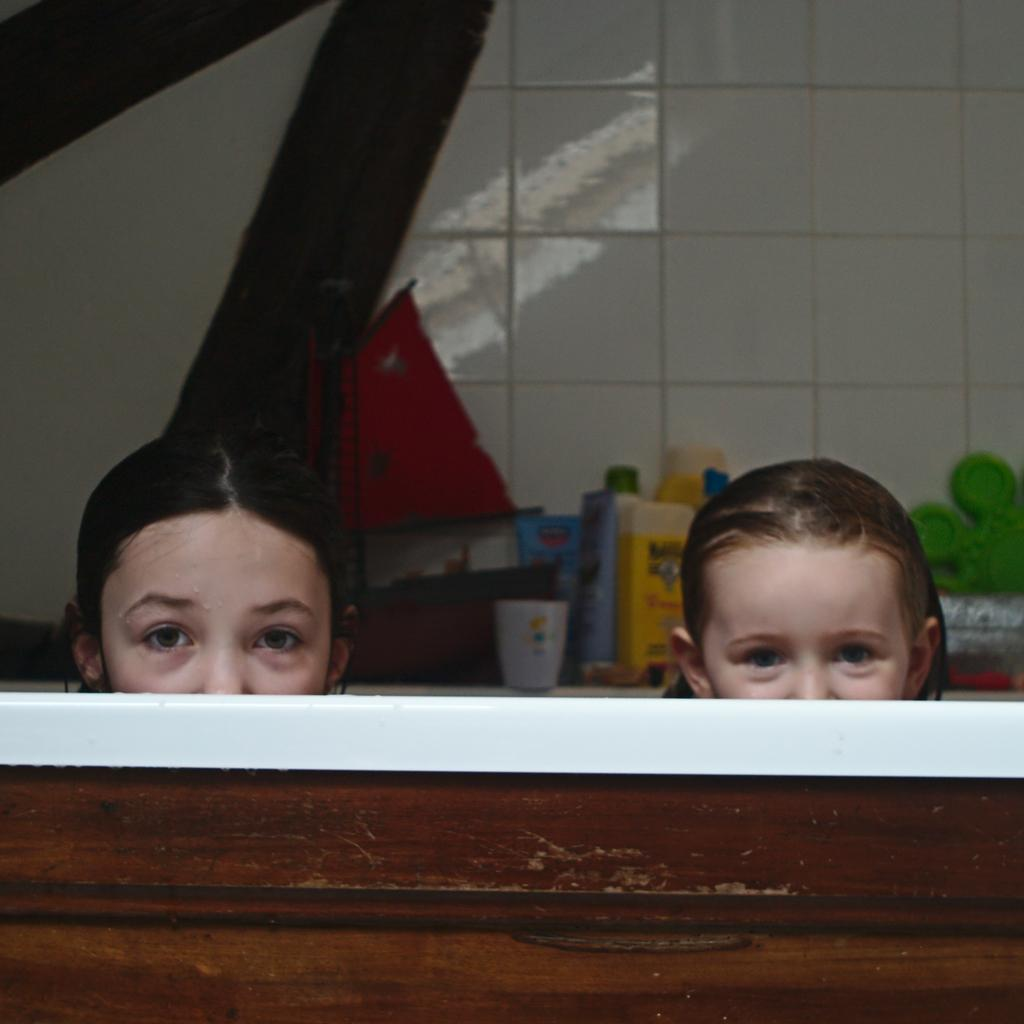How many people are present in the image? There are two people in the image. What can be seen in the background of the image? There are colorful bottles and other objects in the background. What is the color of the background in the image? The background is in white color. Can you see a crown on the head of one of the people in the image? There is no crown visible on the head of either person in the image. 